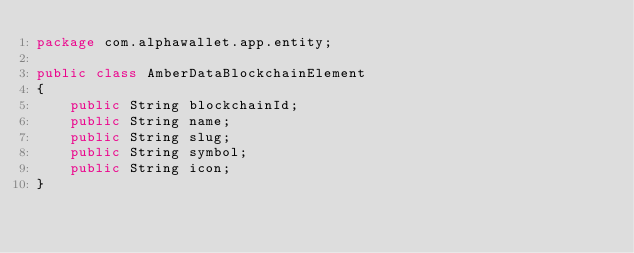Convert code to text. <code><loc_0><loc_0><loc_500><loc_500><_Java_>package com.alphawallet.app.entity;

public class AmberDataBlockchainElement
{
    public String blockchainId;
    public String name;
    public String slug;
    public String symbol;
    public String icon;
}
</code> 